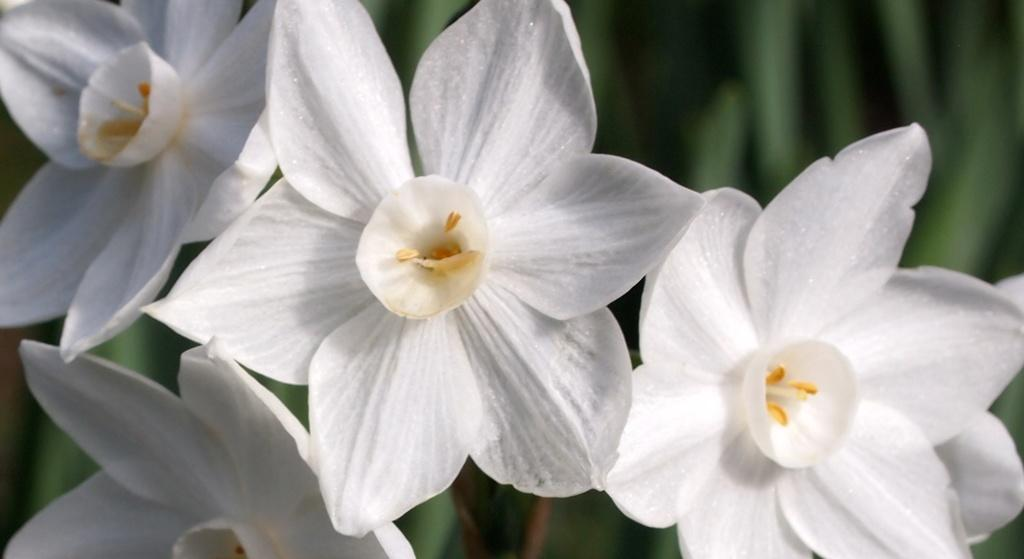What type of flowers can be seen in the image? There are white flowers in the image. What else can be seen in the background of the image? There are leaves visible in the background of the image. How would you describe the clarity of the image? The image is blurry. How many units of snake are present in the image? There are no snakes present in the image; it features white flowers and leaves in the background. 